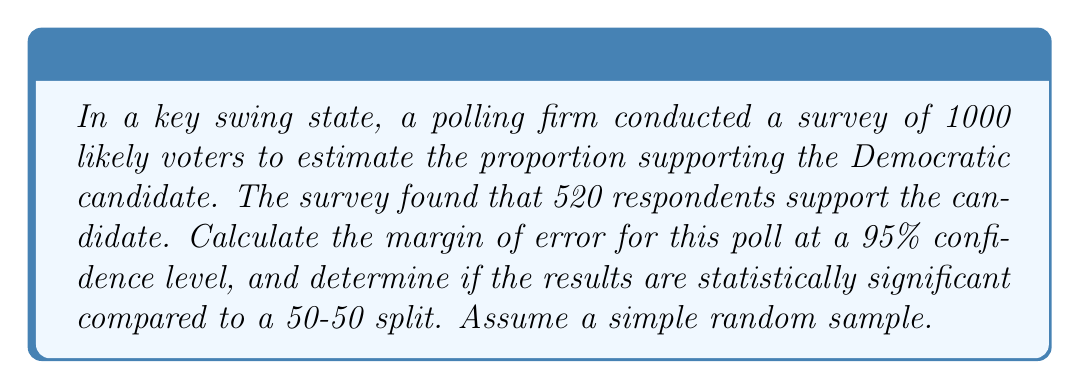Teach me how to tackle this problem. 1. Calculate the sample proportion:
   $p = \frac{520}{1000} = 0.52$

2. Calculate the standard error:
   $SE = \sqrt{\frac{p(1-p)}{n}} = \sqrt{\frac{0.52(1-0.52)}{1000}} = 0.0158$

3. For a 95% confidence level, use z-score of 1.96.

4. Calculate the margin of error:
   $MoE = 1.96 \times SE = 1.96 \times 0.0158 = 0.031$ or 3.1%

5. Construct the confidence interval:
   $CI = p \pm MoE = 0.52 \pm 0.031 = (0.489, 0.551)$

6. To determine statistical significance, check if 0.5 (representing a 50-50 split) is outside the confidence interval.

7. Since 0.5 is within the interval (0.489, 0.551), the results are not statistically significant compared to a 50-50 split at the 95% confidence level.
Answer: Margin of Error: 3.1%. Not statistically significant. 